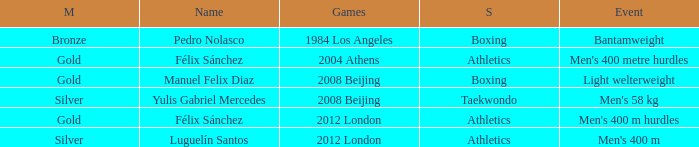Which Games had a Name of manuel felix diaz? 2008 Beijing. 